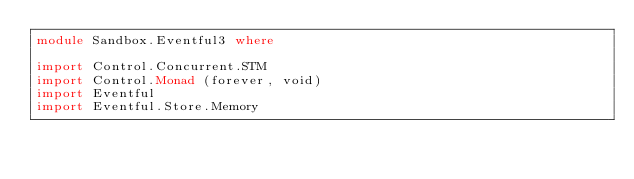<code> <loc_0><loc_0><loc_500><loc_500><_Haskell_>module Sandbox.Eventful3 where

import Control.Concurrent.STM
import Control.Monad (forever, void)
import Eventful
import Eventful.Store.Memory
</code> 